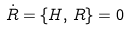<formula> <loc_0><loc_0><loc_500><loc_500>\dot { R } = \{ H , \, R \} = 0</formula> 